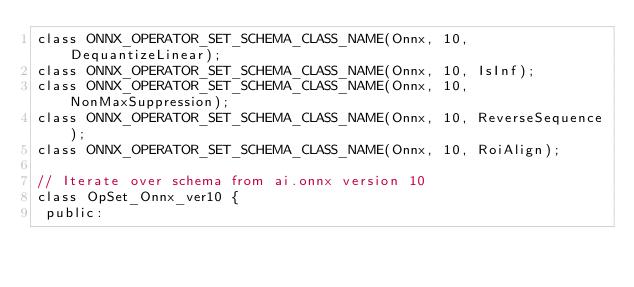Convert code to text. <code><loc_0><loc_0><loc_500><loc_500><_C_>class ONNX_OPERATOR_SET_SCHEMA_CLASS_NAME(Onnx, 10, DequantizeLinear);
class ONNX_OPERATOR_SET_SCHEMA_CLASS_NAME(Onnx, 10, IsInf);
class ONNX_OPERATOR_SET_SCHEMA_CLASS_NAME(Onnx, 10, NonMaxSuppression);
class ONNX_OPERATOR_SET_SCHEMA_CLASS_NAME(Onnx, 10, ReverseSequence);
class ONNX_OPERATOR_SET_SCHEMA_CLASS_NAME(Onnx, 10, RoiAlign);

// Iterate over schema from ai.onnx version 10
class OpSet_Onnx_ver10 {
 public:</code> 